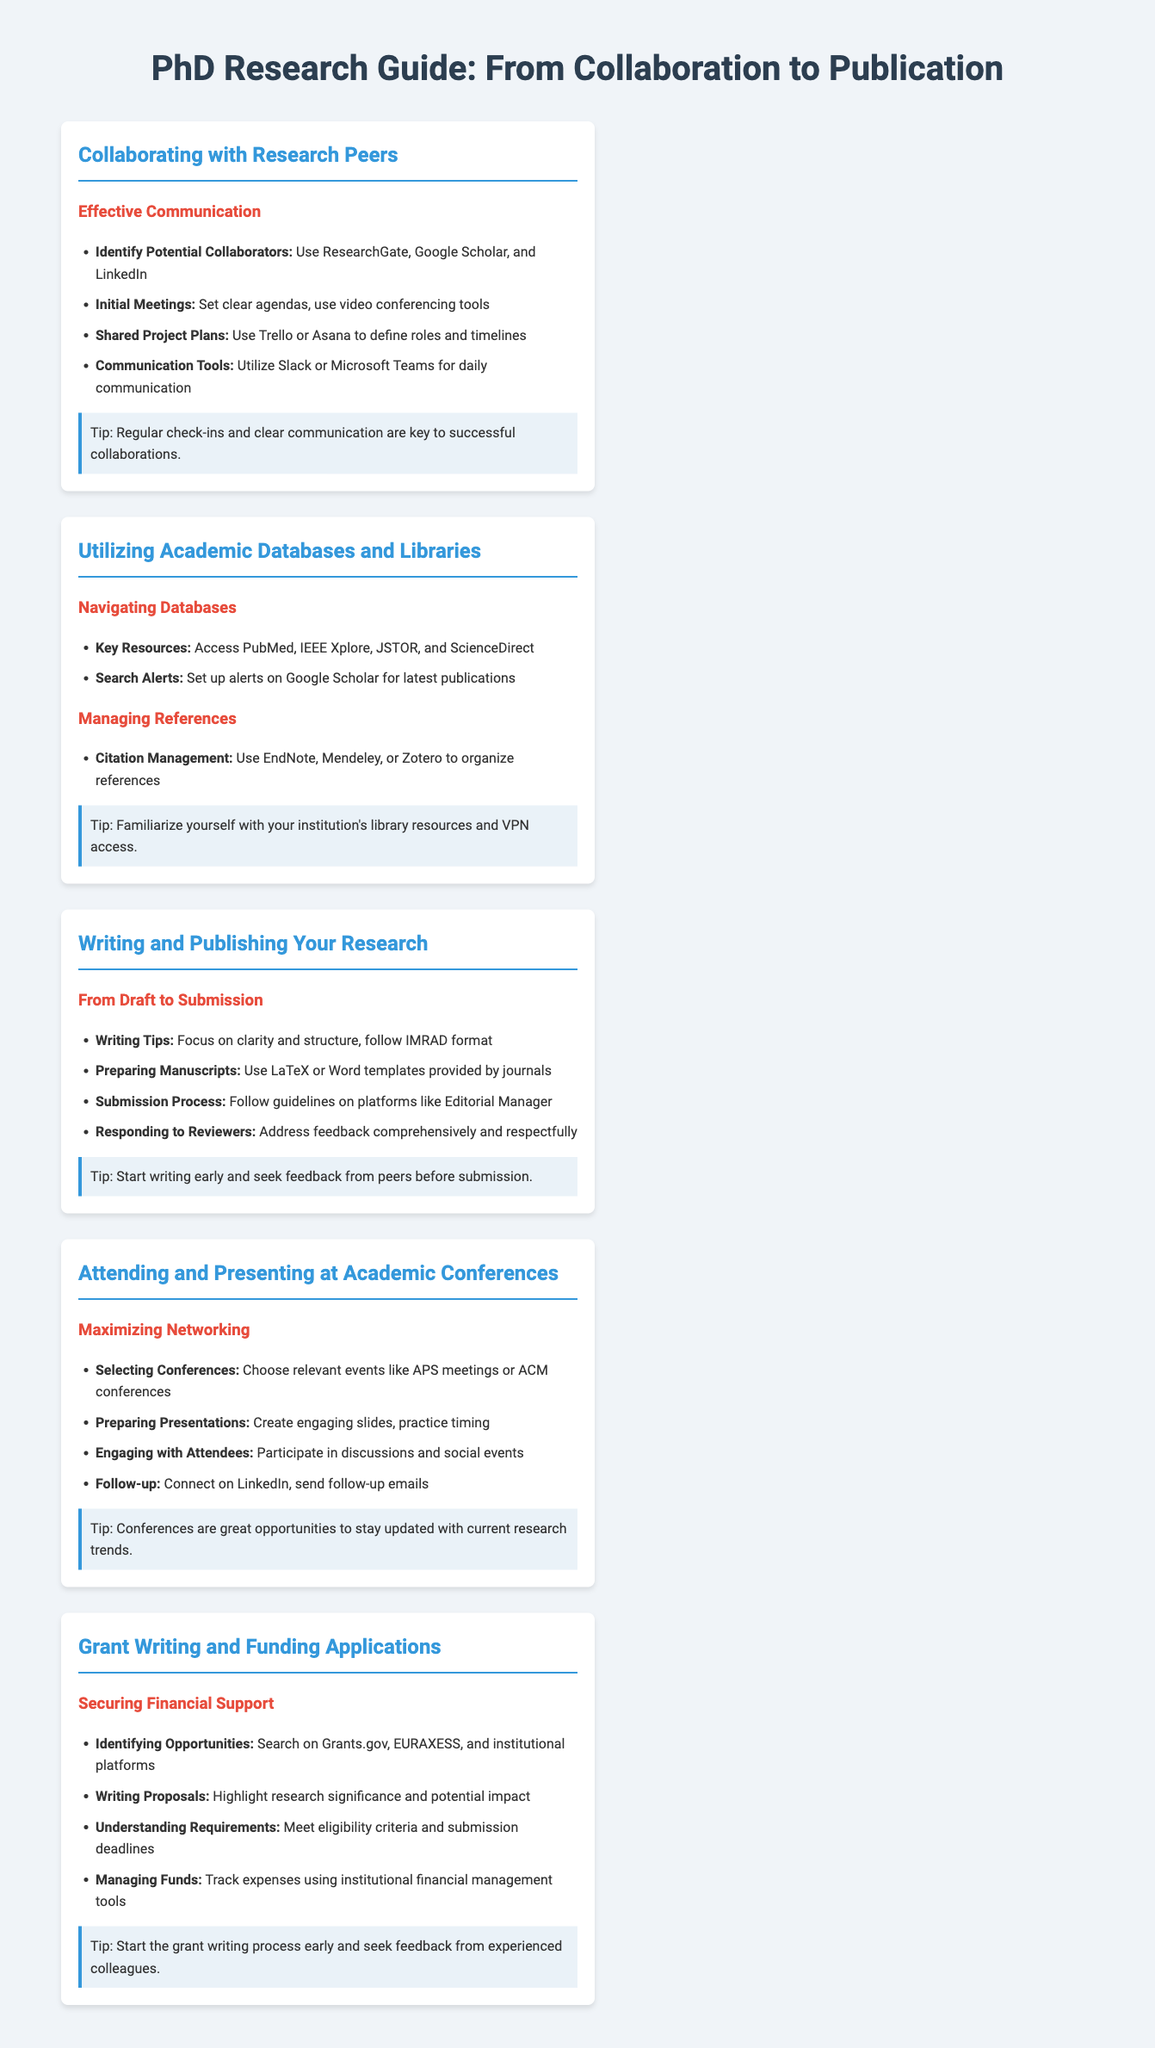what tools can be used for daily communication? The document lists Slack and Microsoft Teams as tools for daily communication.
Answer: Slack, Microsoft Teams which citation management software is recommended? The guide suggests using EndNote, Mendeley, or Zotero for citation management.
Answer: EndNote, Mendeley, Zotero what is the IMRAD format? The document mentions IMRAD as a writing tip, used for structuring research papers.
Answer: IMRAD which databases are key resources for academic research? The guide identifies PubMed, IEEE Xplore, JSTOR, and ScienceDirect as key databases.
Answer: PubMed, IEEE Xplore, JSTOR, ScienceDirect how should you prepare your presentation for conferences? The document advises creating engaging slides and practicing timing for presentations.
Answer: Create engaging slides, practice timing name one website to search for funding opportunities. The guide mentions Grants.gov as a resource for identifying funding opportunities.
Answer: Grants.gov what should you do during follow-up after a conference? The document recommends connecting on LinkedIn and sending follow-up emails after a conference.
Answer: Connect on LinkedIn, send follow-up emails what is a key element for successful collaborations? The guide emphasizes that regular check-ins and clear communication are key.
Answer: Regular check-ins, clear communication how can you set up search alerts for publications? The document suggests setting up alerts on Google Scholar for the latest publications.
Answer: Google Scholar 